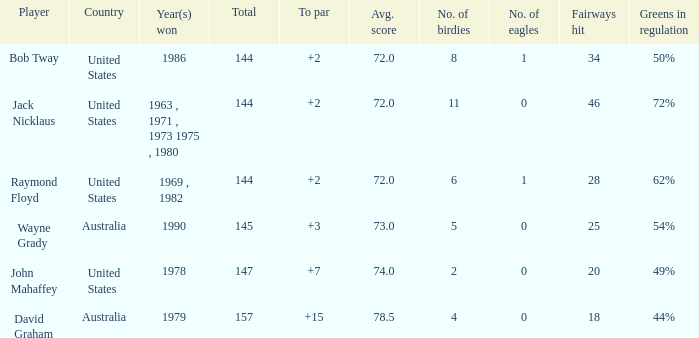How many strokes off par was the winner in 1978? 7.0. 